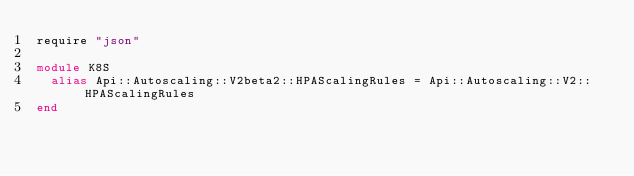Convert code to text. <code><loc_0><loc_0><loc_500><loc_500><_Crystal_>require "json"

module K8S
  alias Api::Autoscaling::V2beta2::HPAScalingRules = Api::Autoscaling::V2::HPAScalingRules
end
</code> 